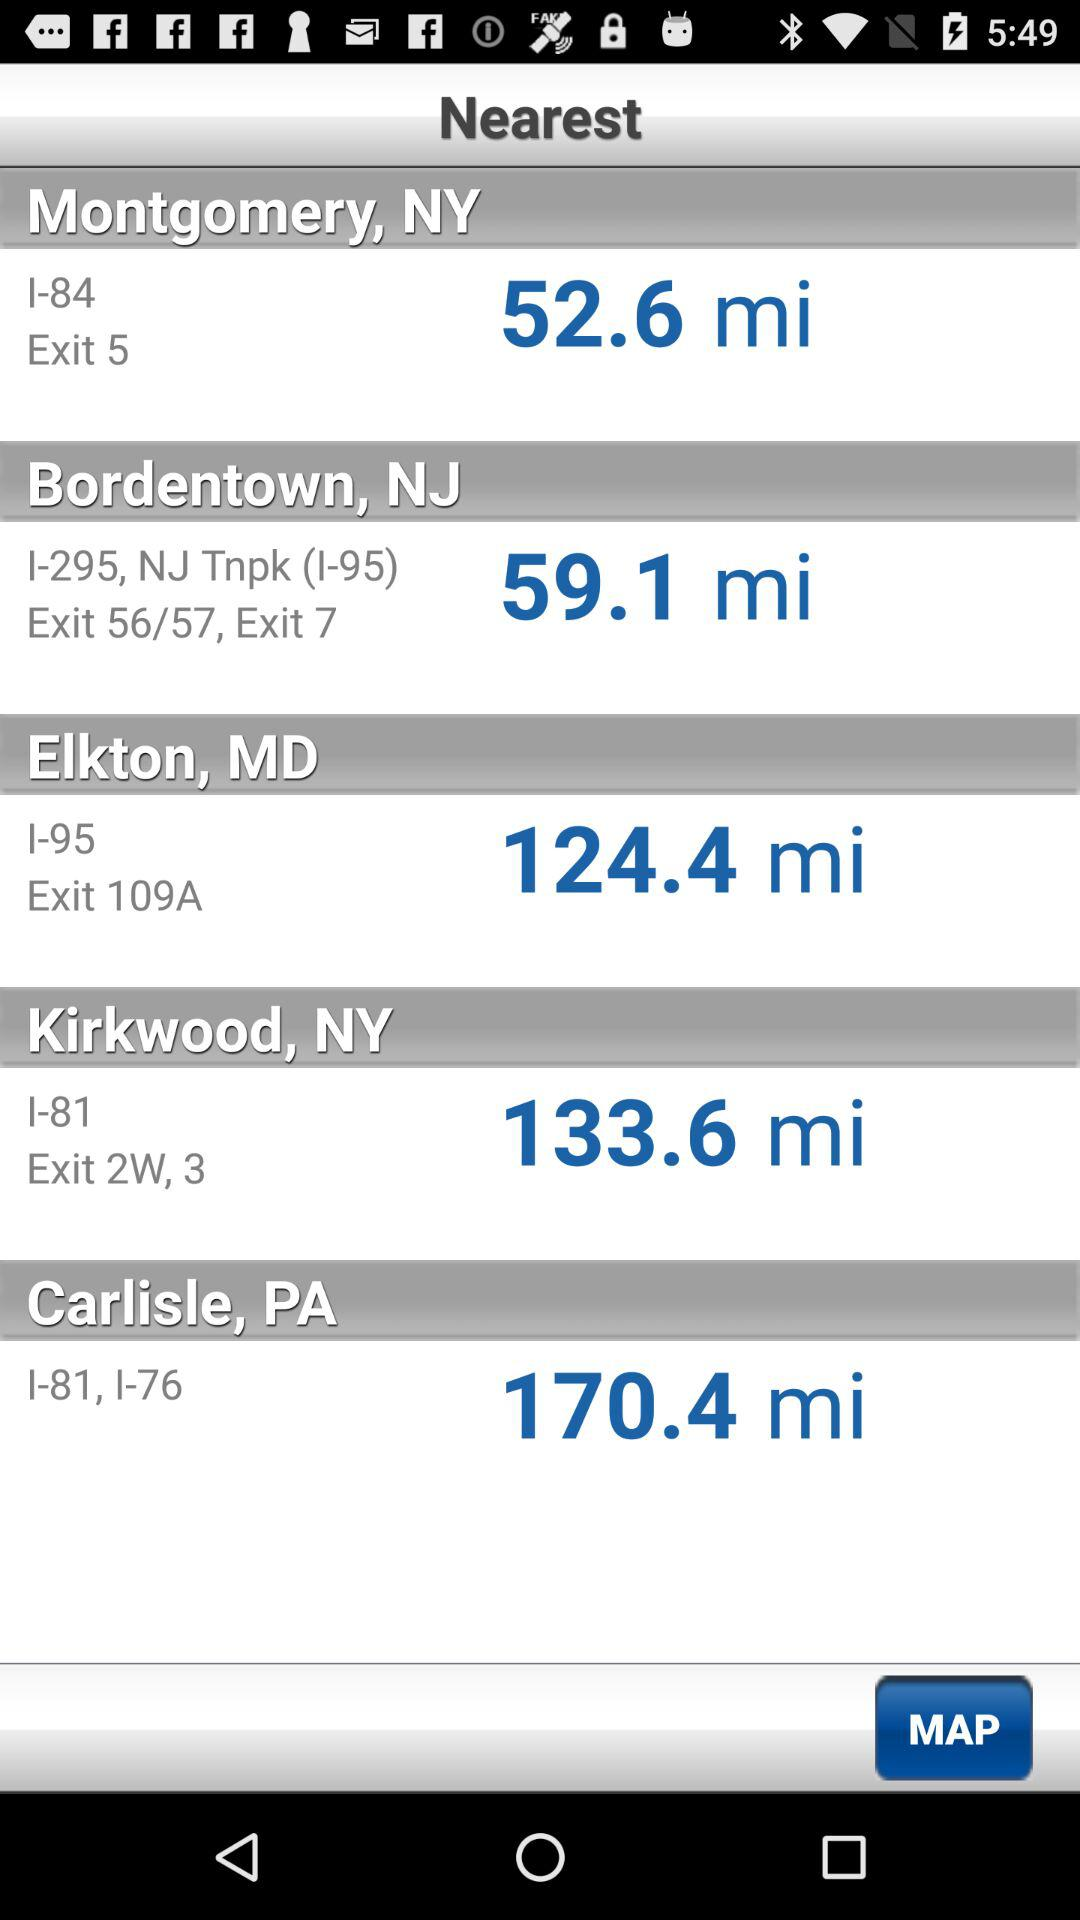What is the Bordentown, NJ address? The Bordentown, NJ address is I-295, NJ Tnpk (I-95) Exit 56/57, Exit 7. 